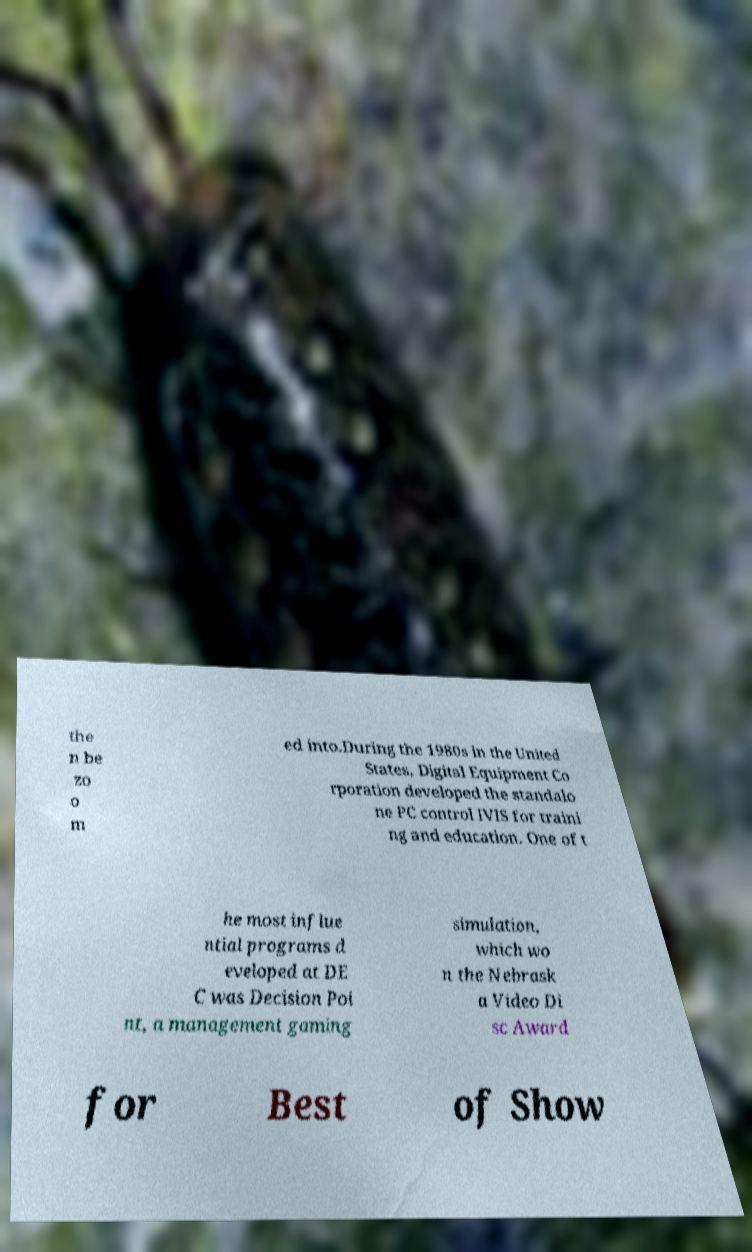Could you extract and type out the text from this image? the n be zo o m ed into.During the 1980s in the United States, Digital Equipment Co rporation developed the standalo ne PC control IVIS for traini ng and education. One of t he most influe ntial programs d eveloped at DE C was Decision Poi nt, a management gaming simulation, which wo n the Nebrask a Video Di sc Award for Best of Show 